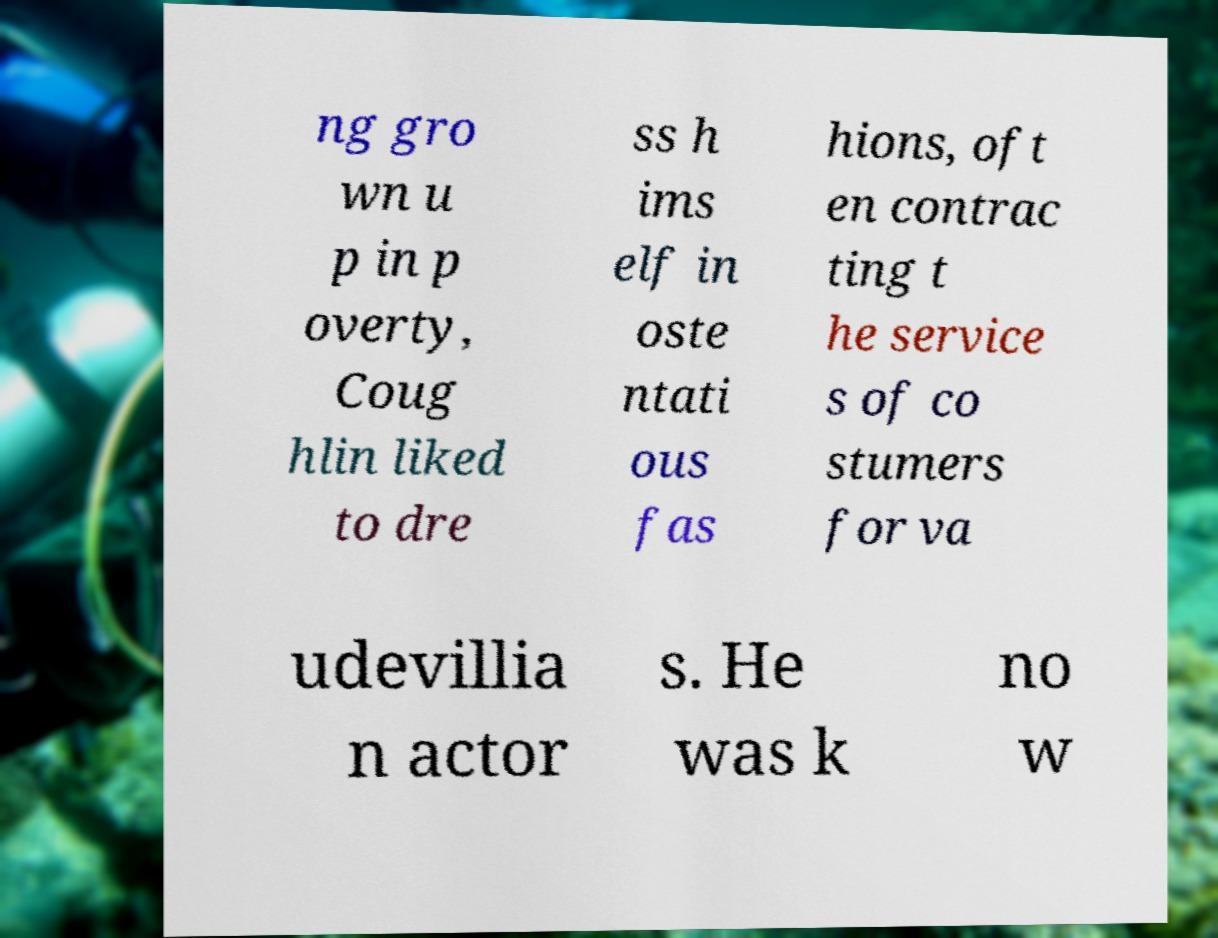Can you accurately transcribe the text from the provided image for me? ng gro wn u p in p overty, Coug hlin liked to dre ss h ims elf in oste ntati ous fas hions, oft en contrac ting t he service s of co stumers for va udevillia n actor s. He was k no w 